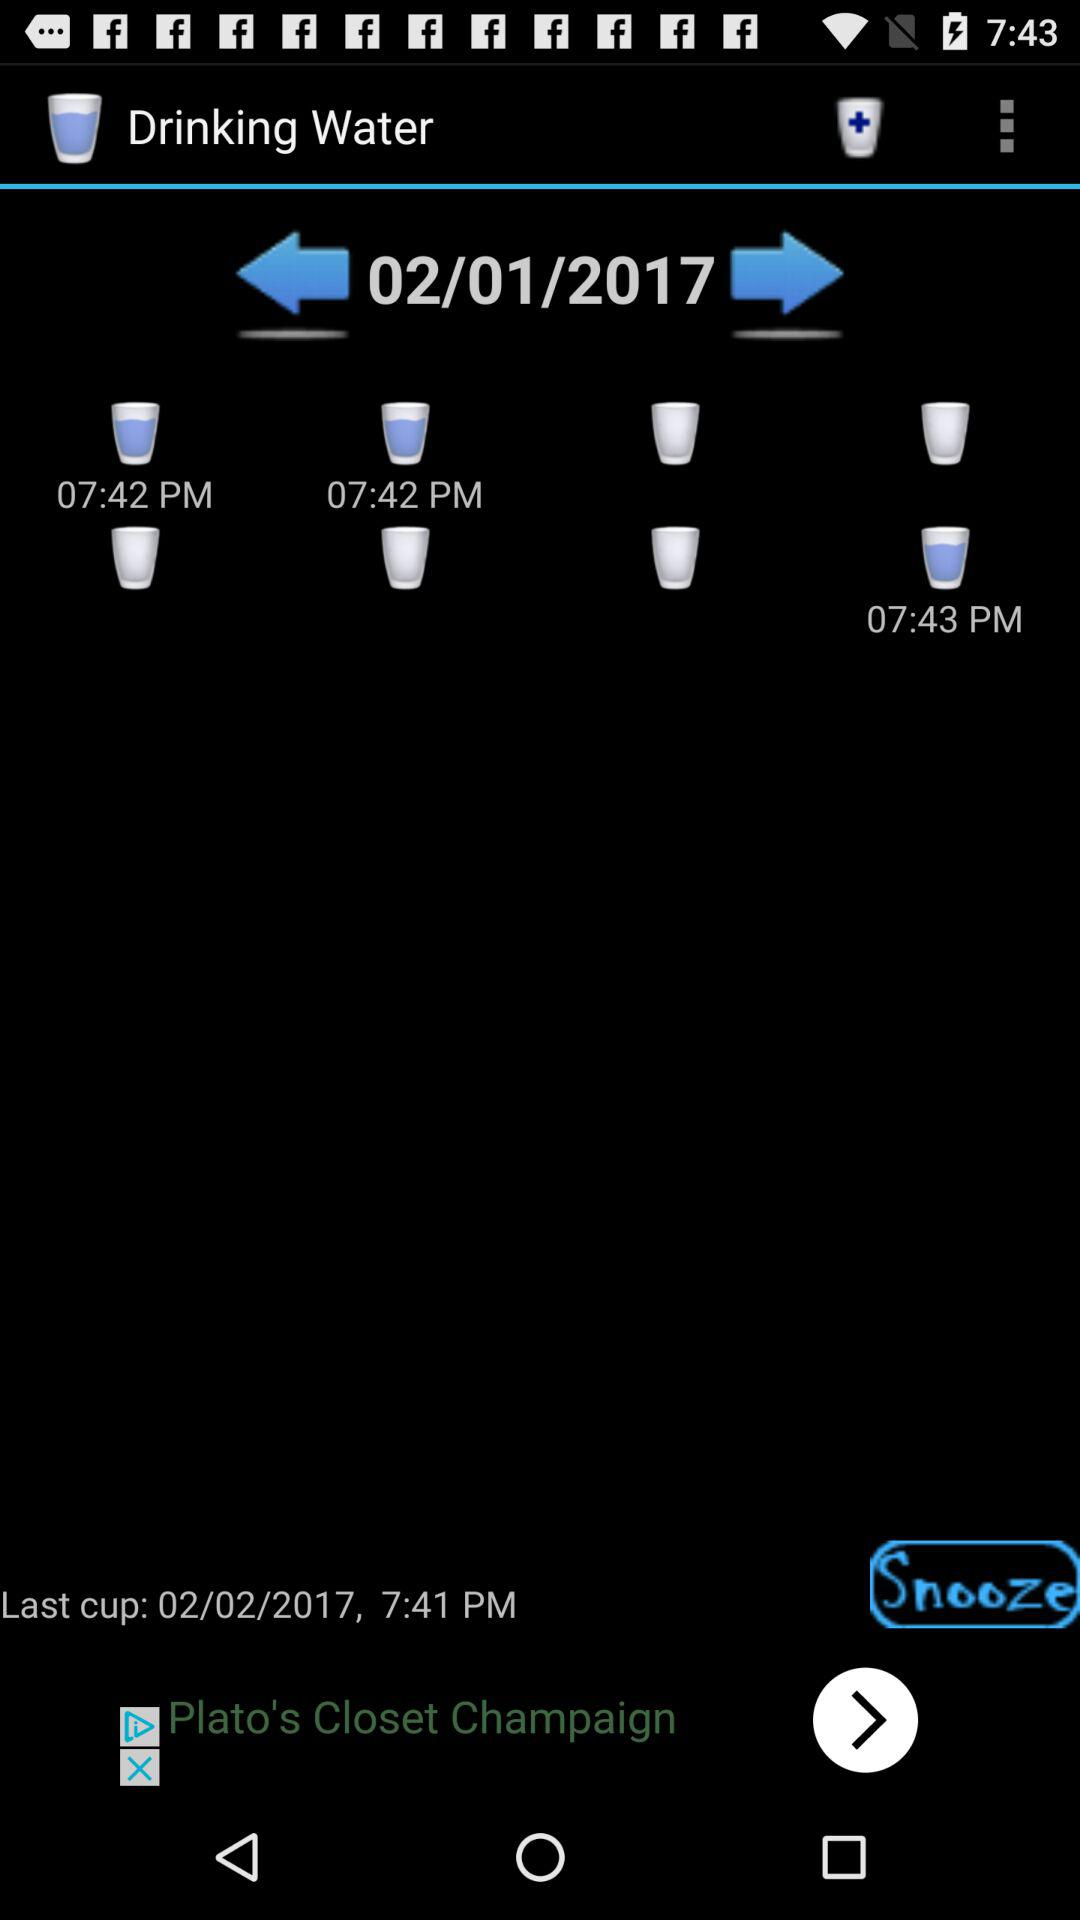On what date was the last cup of water drunk? The last cup of water was drunk on February 2, 2017. 